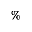Convert formula to latex. <formula><loc_0><loc_0><loc_500><loc_500>\%</formula> 